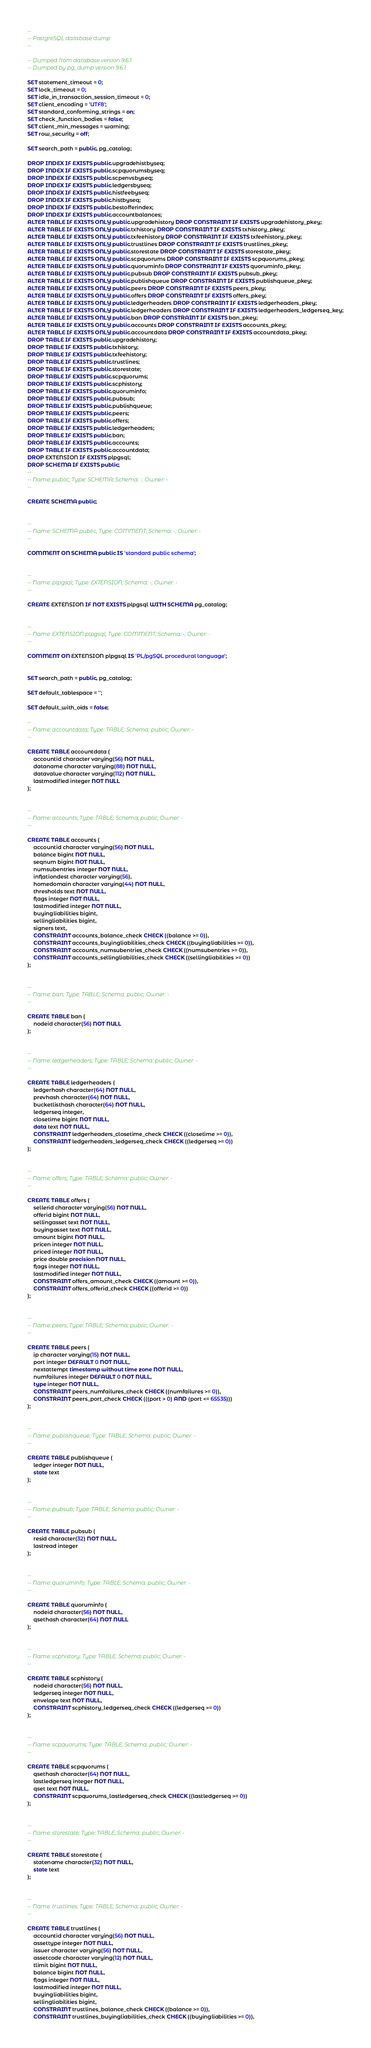<code> <loc_0><loc_0><loc_500><loc_500><_SQL_>--
-- PostgreSQL database dump
--

-- Dumped from database version 9.6.1
-- Dumped by pg_dump version 9.6.1

SET statement_timeout = 0;
SET lock_timeout = 0;
SET idle_in_transaction_session_timeout = 0;
SET client_encoding = 'UTF8';
SET standard_conforming_strings = on;
SET check_function_bodies = false;
SET client_min_messages = warning;
SET row_security = off;

SET search_path = public, pg_catalog;

DROP INDEX IF EXISTS public.upgradehistbyseq;
DROP INDEX IF EXISTS public.scpquorumsbyseq;
DROP INDEX IF EXISTS public.scpenvsbyseq;
DROP INDEX IF EXISTS public.ledgersbyseq;
DROP INDEX IF EXISTS public.histfeebyseq;
DROP INDEX IF EXISTS public.histbyseq;
DROP INDEX IF EXISTS public.bestofferindex;
DROP INDEX IF EXISTS public.accountbalances;
ALTER TABLE IF EXISTS ONLY public.upgradehistory DROP CONSTRAINT IF EXISTS upgradehistory_pkey;
ALTER TABLE IF EXISTS ONLY public.txhistory DROP CONSTRAINT IF EXISTS txhistory_pkey;
ALTER TABLE IF EXISTS ONLY public.txfeehistory DROP CONSTRAINT IF EXISTS txfeehistory_pkey;
ALTER TABLE IF EXISTS ONLY public.trustlines DROP CONSTRAINT IF EXISTS trustlines_pkey;
ALTER TABLE IF EXISTS ONLY public.storestate DROP CONSTRAINT IF EXISTS storestate_pkey;
ALTER TABLE IF EXISTS ONLY public.scpquorums DROP CONSTRAINT IF EXISTS scpquorums_pkey;
ALTER TABLE IF EXISTS ONLY public.quoruminfo DROP CONSTRAINT IF EXISTS quoruminfo_pkey;
ALTER TABLE IF EXISTS ONLY public.pubsub DROP CONSTRAINT IF EXISTS pubsub_pkey;
ALTER TABLE IF EXISTS ONLY public.publishqueue DROP CONSTRAINT IF EXISTS publishqueue_pkey;
ALTER TABLE IF EXISTS ONLY public.peers DROP CONSTRAINT IF EXISTS peers_pkey;
ALTER TABLE IF EXISTS ONLY public.offers DROP CONSTRAINT IF EXISTS offers_pkey;
ALTER TABLE IF EXISTS ONLY public.ledgerheaders DROP CONSTRAINT IF EXISTS ledgerheaders_pkey;
ALTER TABLE IF EXISTS ONLY public.ledgerheaders DROP CONSTRAINT IF EXISTS ledgerheaders_ledgerseq_key;
ALTER TABLE IF EXISTS ONLY public.ban DROP CONSTRAINT IF EXISTS ban_pkey;
ALTER TABLE IF EXISTS ONLY public.accounts DROP CONSTRAINT IF EXISTS accounts_pkey;
ALTER TABLE IF EXISTS ONLY public.accountdata DROP CONSTRAINT IF EXISTS accountdata_pkey;
DROP TABLE IF EXISTS public.upgradehistory;
DROP TABLE IF EXISTS public.txhistory;
DROP TABLE IF EXISTS public.txfeehistory;
DROP TABLE IF EXISTS public.trustlines;
DROP TABLE IF EXISTS public.storestate;
DROP TABLE IF EXISTS public.scpquorums;
DROP TABLE IF EXISTS public.scphistory;
DROP TABLE IF EXISTS public.quoruminfo;
DROP TABLE IF EXISTS public.pubsub;
DROP TABLE IF EXISTS public.publishqueue;
DROP TABLE IF EXISTS public.peers;
DROP TABLE IF EXISTS public.offers;
DROP TABLE IF EXISTS public.ledgerheaders;
DROP TABLE IF EXISTS public.ban;
DROP TABLE IF EXISTS public.accounts;
DROP TABLE IF EXISTS public.accountdata;
DROP EXTENSION IF EXISTS plpgsql;
DROP SCHEMA IF EXISTS public;
--
-- Name: public; Type: SCHEMA; Schema: -; Owner: -
--

CREATE SCHEMA public;


--
-- Name: SCHEMA public; Type: COMMENT; Schema: -; Owner: -
--

COMMENT ON SCHEMA public IS 'standard public schema';


--
-- Name: plpgsql; Type: EXTENSION; Schema: -; Owner: -
--

CREATE EXTENSION IF NOT EXISTS plpgsql WITH SCHEMA pg_catalog;


--
-- Name: EXTENSION plpgsql; Type: COMMENT; Schema: -; Owner: -
--

COMMENT ON EXTENSION plpgsql IS 'PL/pgSQL procedural language';


SET search_path = public, pg_catalog;

SET default_tablespace = '';

SET default_with_oids = false;

--
-- Name: accountdata; Type: TABLE; Schema: public; Owner: -
--

CREATE TABLE accountdata (
    accountid character varying(56) NOT NULL,
    dataname character varying(88) NOT NULL,
    datavalue character varying(112) NOT NULL,
    lastmodified integer NOT NULL
);


--
-- Name: accounts; Type: TABLE; Schema: public; Owner: -
--

CREATE TABLE accounts (
    accountid character varying(56) NOT NULL,
    balance bigint NOT NULL,
    seqnum bigint NOT NULL,
    numsubentries integer NOT NULL,
    inflationdest character varying(56),
    homedomain character varying(44) NOT NULL,
    thresholds text NOT NULL,
    flags integer NOT NULL,
    lastmodified integer NOT NULL,
    buyingliabilities bigint,
    sellingliabilities bigint,
    signers text,
    CONSTRAINT accounts_balance_check CHECK ((balance >= 0)),
    CONSTRAINT accounts_buyingliabilities_check CHECK ((buyingliabilities >= 0)),
    CONSTRAINT accounts_numsubentries_check CHECK ((numsubentries >= 0)),
    CONSTRAINT accounts_sellingliabilities_check CHECK ((sellingliabilities >= 0))
);


--
-- Name: ban; Type: TABLE; Schema: public; Owner: -
--

CREATE TABLE ban (
    nodeid character(56) NOT NULL
);


--
-- Name: ledgerheaders; Type: TABLE; Schema: public; Owner: -
--

CREATE TABLE ledgerheaders (
    ledgerhash character(64) NOT NULL,
    prevhash character(64) NOT NULL,
    bucketlisthash character(64) NOT NULL,
    ledgerseq integer,
    closetime bigint NOT NULL,
    data text NOT NULL,
    CONSTRAINT ledgerheaders_closetime_check CHECK ((closetime >= 0)),
    CONSTRAINT ledgerheaders_ledgerseq_check CHECK ((ledgerseq >= 0))
);


--
-- Name: offers; Type: TABLE; Schema: public; Owner: -
--

CREATE TABLE offers (
    sellerid character varying(56) NOT NULL,
    offerid bigint NOT NULL,
    sellingasset text NOT NULL,
    buyingasset text NOT NULL,
    amount bigint NOT NULL,
    pricen integer NOT NULL,
    priced integer NOT NULL,
    price double precision NOT NULL,
    flags integer NOT NULL,
    lastmodified integer NOT NULL,
    CONSTRAINT offers_amount_check CHECK ((amount >= 0)),
    CONSTRAINT offers_offerid_check CHECK ((offerid >= 0))
);


--
-- Name: peers; Type: TABLE; Schema: public; Owner: -
--

CREATE TABLE peers (
    ip character varying(15) NOT NULL,
    port integer DEFAULT 0 NOT NULL,
    nextattempt timestamp without time zone NOT NULL,
    numfailures integer DEFAULT 0 NOT NULL,
    type integer NOT NULL,
    CONSTRAINT peers_numfailures_check CHECK ((numfailures >= 0)),
    CONSTRAINT peers_port_check CHECK (((port > 0) AND (port <= 65535)))
);


--
-- Name: publishqueue; Type: TABLE; Schema: public; Owner: -
--

CREATE TABLE publishqueue (
    ledger integer NOT NULL,
    state text
);


--
-- Name: pubsub; Type: TABLE; Schema: public; Owner: -
--

CREATE TABLE pubsub (
    resid character(32) NOT NULL,
    lastread integer
);


--
-- Name: quoruminfo; Type: TABLE; Schema: public; Owner: -
--

CREATE TABLE quoruminfo (
    nodeid character(56) NOT NULL,
    qsethash character(64) NOT NULL
);


--
-- Name: scphistory; Type: TABLE; Schema: public; Owner: -
--

CREATE TABLE scphistory (
    nodeid character(56) NOT NULL,
    ledgerseq integer NOT NULL,
    envelope text NOT NULL,
    CONSTRAINT scphistory_ledgerseq_check CHECK ((ledgerseq >= 0))
);


--
-- Name: scpquorums; Type: TABLE; Schema: public; Owner: -
--

CREATE TABLE scpquorums (
    qsethash character(64) NOT NULL,
    lastledgerseq integer NOT NULL,
    qset text NOT NULL,
    CONSTRAINT scpquorums_lastledgerseq_check CHECK ((lastledgerseq >= 0))
);


--
-- Name: storestate; Type: TABLE; Schema: public; Owner: -
--

CREATE TABLE storestate (
    statename character(32) NOT NULL,
    state text
);


--
-- Name: trustlines; Type: TABLE; Schema: public; Owner: -
--

CREATE TABLE trustlines (
    accountid character varying(56) NOT NULL,
    assettype integer NOT NULL,
    issuer character varying(56) NOT NULL,
    assetcode character varying(12) NOT NULL,
    tlimit bigint NOT NULL,
    balance bigint NOT NULL,
    flags integer NOT NULL,
    lastmodified integer NOT NULL,
    buyingliabilities bigint,
    sellingliabilities bigint,
    CONSTRAINT trustlines_balance_check CHECK ((balance >= 0)),
    CONSTRAINT trustlines_buyingliabilities_check CHECK ((buyingliabilities >= 0)),</code> 